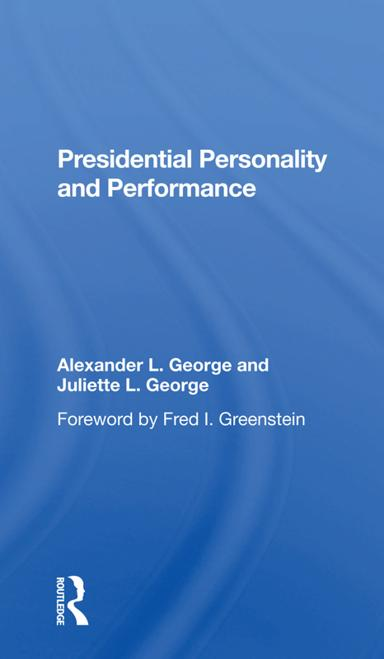Can you discuss the significance of presidential personality in political performance according to the book? Certainly! According to 'Presidential Personality and Performance,' personal attributes such as decision-making style, emotional intelligence, and leadership qualities critically affect a president's ability to govern effectively and manage crises. 